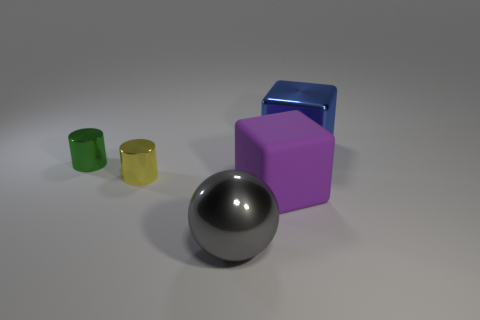Add 4 large brown shiny things. How many objects exist? 9 Subtract all cubes. How many objects are left? 3 Subtract all rubber cylinders. Subtract all large gray metal spheres. How many objects are left? 4 Add 4 big gray balls. How many big gray balls are left? 5 Add 2 large blue shiny cubes. How many large blue shiny cubes exist? 3 Subtract 0 cyan spheres. How many objects are left? 5 